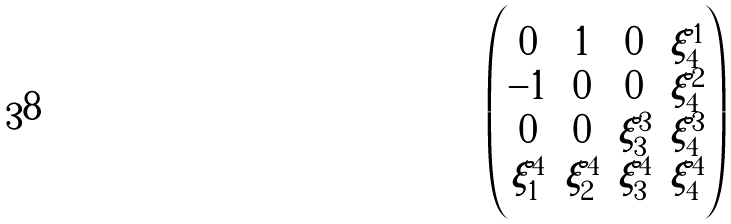<formula> <loc_0><loc_0><loc_500><loc_500>\begin{pmatrix} 0 & 1 & 0 & \xi ^ { 1 } _ { 4 } \\ - 1 & 0 & 0 & \xi ^ { 2 } _ { 4 } \\ 0 & 0 & \xi ^ { 3 } _ { 3 } & \xi ^ { 3 } _ { 4 } \\ \xi ^ { 4 } _ { 1 } & \xi ^ { 4 } _ { 2 } & \xi ^ { 4 } _ { 3 } & \xi ^ { 4 } _ { 4 } \end{pmatrix}</formula> 